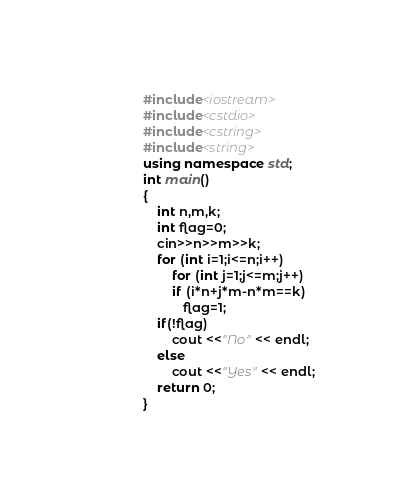Convert code to text. <code><loc_0><loc_0><loc_500><loc_500><_C++_>#include<iostream>
#include<cstdio>
#include<cstring>
#include<string>
using namespace std;
int main()
{
    int n,m,k;
    int flag=0;
    cin>>n>>m>>k;
    for (int i=1;i<=n;i++)
        for (int j=1;j<=m;j++)
        if (i*n+j*m-n*m==k)
           flag=1;
    if(!flag)
        cout <<"No" << endl;
    else
        cout <<"Yes" << endl;
    return 0;
}
</code> 